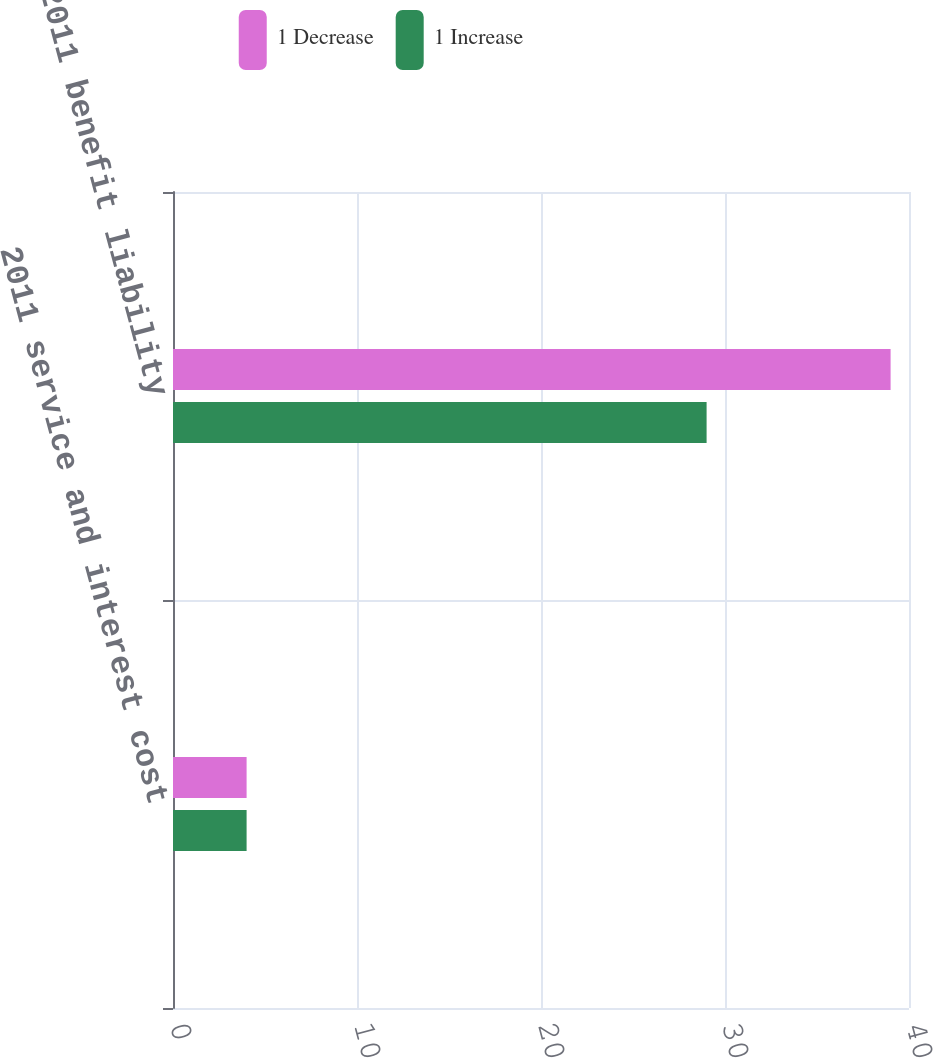Convert chart to OTSL. <chart><loc_0><loc_0><loc_500><loc_500><stacked_bar_chart><ecel><fcel>2011 service and interest cost<fcel>2011 benefit liability<nl><fcel>1 Decrease<fcel>4<fcel>39<nl><fcel>1 Increase<fcel>4<fcel>29<nl></chart> 